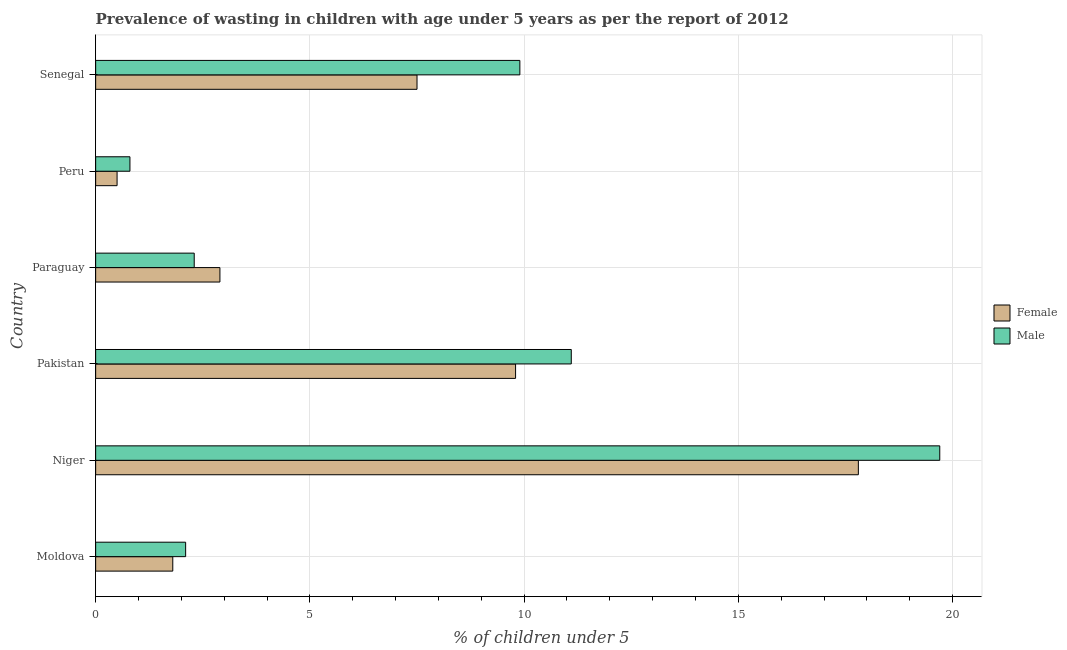How many different coloured bars are there?
Your answer should be compact. 2. Are the number of bars per tick equal to the number of legend labels?
Keep it short and to the point. Yes. Are the number of bars on each tick of the Y-axis equal?
Make the answer very short. Yes. How many bars are there on the 6th tick from the bottom?
Offer a terse response. 2. What is the label of the 6th group of bars from the top?
Provide a short and direct response. Moldova. What is the percentage of undernourished female children in Pakistan?
Your answer should be compact. 9.8. Across all countries, what is the maximum percentage of undernourished male children?
Provide a short and direct response. 19.7. Across all countries, what is the minimum percentage of undernourished male children?
Provide a short and direct response. 0.8. In which country was the percentage of undernourished male children maximum?
Make the answer very short. Niger. In which country was the percentage of undernourished female children minimum?
Your response must be concise. Peru. What is the total percentage of undernourished female children in the graph?
Offer a very short reply. 40.3. What is the difference between the percentage of undernourished male children in Moldova and the percentage of undernourished female children in Paraguay?
Your answer should be very brief. -0.8. What is the average percentage of undernourished male children per country?
Your answer should be compact. 7.65. In how many countries, is the percentage of undernourished male children greater than 9 %?
Offer a terse response. 3. What is the ratio of the percentage of undernourished female children in Niger to that in Senegal?
Offer a terse response. 2.37. What is the difference between the highest and the lowest percentage of undernourished female children?
Offer a terse response. 17.3. In how many countries, is the percentage of undernourished female children greater than the average percentage of undernourished female children taken over all countries?
Provide a succinct answer. 3. Is the sum of the percentage of undernourished male children in Moldova and Paraguay greater than the maximum percentage of undernourished female children across all countries?
Keep it short and to the point. No. What does the 1st bar from the top in Pakistan represents?
Your answer should be very brief. Male. What does the 2nd bar from the bottom in Paraguay represents?
Keep it short and to the point. Male. Are the values on the major ticks of X-axis written in scientific E-notation?
Provide a succinct answer. No. How many legend labels are there?
Provide a succinct answer. 2. How are the legend labels stacked?
Your answer should be compact. Vertical. What is the title of the graph?
Provide a short and direct response. Prevalence of wasting in children with age under 5 years as per the report of 2012. Does "Nitrous oxide emissions" appear as one of the legend labels in the graph?
Give a very brief answer. No. What is the label or title of the X-axis?
Provide a short and direct response.  % of children under 5. What is the  % of children under 5 in Female in Moldova?
Offer a very short reply. 1.8. What is the  % of children under 5 in Male in Moldova?
Offer a terse response. 2.1. What is the  % of children under 5 of Female in Niger?
Keep it short and to the point. 17.8. What is the  % of children under 5 in Male in Niger?
Your answer should be compact. 19.7. What is the  % of children under 5 in Female in Pakistan?
Offer a terse response. 9.8. What is the  % of children under 5 in Male in Pakistan?
Ensure brevity in your answer.  11.1. What is the  % of children under 5 of Female in Paraguay?
Ensure brevity in your answer.  2.9. What is the  % of children under 5 of Male in Paraguay?
Your answer should be compact. 2.3. What is the  % of children under 5 in Female in Peru?
Offer a terse response. 0.5. What is the  % of children under 5 of Male in Peru?
Make the answer very short. 0.8. What is the  % of children under 5 in Male in Senegal?
Offer a terse response. 9.9. Across all countries, what is the maximum  % of children under 5 in Female?
Provide a succinct answer. 17.8. Across all countries, what is the maximum  % of children under 5 of Male?
Offer a very short reply. 19.7. Across all countries, what is the minimum  % of children under 5 in Male?
Your response must be concise. 0.8. What is the total  % of children under 5 of Female in the graph?
Your response must be concise. 40.3. What is the total  % of children under 5 of Male in the graph?
Offer a very short reply. 45.9. What is the difference between the  % of children under 5 in Female in Moldova and that in Niger?
Your answer should be very brief. -16. What is the difference between the  % of children under 5 of Male in Moldova and that in Niger?
Your response must be concise. -17.6. What is the difference between the  % of children under 5 of Male in Moldova and that in Pakistan?
Provide a succinct answer. -9. What is the difference between the  % of children under 5 in Male in Moldova and that in Paraguay?
Provide a short and direct response. -0.2. What is the difference between the  % of children under 5 in Male in Moldova and that in Peru?
Give a very brief answer. 1.3. What is the difference between the  % of children under 5 of Female in Moldova and that in Senegal?
Your answer should be compact. -5.7. What is the difference between the  % of children under 5 in Male in Niger and that in Paraguay?
Offer a very short reply. 17.4. What is the difference between the  % of children under 5 in Female in Niger and that in Peru?
Offer a very short reply. 17.3. What is the difference between the  % of children under 5 of Female in Pakistan and that in Paraguay?
Make the answer very short. 6.9. What is the difference between the  % of children under 5 of Female in Pakistan and that in Peru?
Ensure brevity in your answer.  9.3. What is the difference between the  % of children under 5 in Male in Pakistan and that in Peru?
Offer a terse response. 10.3. What is the difference between the  % of children under 5 of Male in Pakistan and that in Senegal?
Offer a terse response. 1.2. What is the difference between the  % of children under 5 in Male in Paraguay and that in Senegal?
Provide a short and direct response. -7.6. What is the difference between the  % of children under 5 in Female in Peru and that in Senegal?
Provide a short and direct response. -7. What is the difference between the  % of children under 5 of Female in Moldova and the  % of children under 5 of Male in Niger?
Give a very brief answer. -17.9. What is the difference between the  % of children under 5 in Female in Moldova and the  % of children under 5 in Male in Paraguay?
Offer a very short reply. -0.5. What is the difference between the  % of children under 5 in Female in Moldova and the  % of children under 5 in Male in Peru?
Your answer should be very brief. 1. What is the difference between the  % of children under 5 of Female in Niger and the  % of children under 5 of Male in Pakistan?
Provide a short and direct response. 6.7. What is the difference between the  % of children under 5 of Female in Pakistan and the  % of children under 5 of Male in Senegal?
Your answer should be compact. -0.1. What is the average  % of children under 5 of Female per country?
Make the answer very short. 6.72. What is the average  % of children under 5 of Male per country?
Your response must be concise. 7.65. What is the difference between the  % of children under 5 of Female and  % of children under 5 of Male in Niger?
Offer a terse response. -1.9. What is the difference between the  % of children under 5 in Female and  % of children under 5 in Male in Paraguay?
Ensure brevity in your answer.  0.6. What is the difference between the  % of children under 5 of Female and  % of children under 5 of Male in Peru?
Ensure brevity in your answer.  -0.3. What is the ratio of the  % of children under 5 in Female in Moldova to that in Niger?
Your answer should be compact. 0.1. What is the ratio of the  % of children under 5 of Male in Moldova to that in Niger?
Make the answer very short. 0.11. What is the ratio of the  % of children under 5 of Female in Moldova to that in Pakistan?
Give a very brief answer. 0.18. What is the ratio of the  % of children under 5 of Male in Moldova to that in Pakistan?
Your answer should be very brief. 0.19. What is the ratio of the  % of children under 5 in Female in Moldova to that in Paraguay?
Make the answer very short. 0.62. What is the ratio of the  % of children under 5 of Male in Moldova to that in Peru?
Provide a short and direct response. 2.62. What is the ratio of the  % of children under 5 in Female in Moldova to that in Senegal?
Provide a succinct answer. 0.24. What is the ratio of the  % of children under 5 in Male in Moldova to that in Senegal?
Your answer should be very brief. 0.21. What is the ratio of the  % of children under 5 of Female in Niger to that in Pakistan?
Your answer should be very brief. 1.82. What is the ratio of the  % of children under 5 of Male in Niger to that in Pakistan?
Give a very brief answer. 1.77. What is the ratio of the  % of children under 5 of Female in Niger to that in Paraguay?
Provide a succinct answer. 6.14. What is the ratio of the  % of children under 5 in Male in Niger to that in Paraguay?
Your answer should be compact. 8.57. What is the ratio of the  % of children under 5 of Female in Niger to that in Peru?
Provide a succinct answer. 35.6. What is the ratio of the  % of children under 5 of Male in Niger to that in Peru?
Your answer should be very brief. 24.62. What is the ratio of the  % of children under 5 of Female in Niger to that in Senegal?
Provide a succinct answer. 2.37. What is the ratio of the  % of children under 5 in Male in Niger to that in Senegal?
Your answer should be compact. 1.99. What is the ratio of the  % of children under 5 in Female in Pakistan to that in Paraguay?
Give a very brief answer. 3.38. What is the ratio of the  % of children under 5 of Male in Pakistan to that in Paraguay?
Keep it short and to the point. 4.83. What is the ratio of the  % of children under 5 of Female in Pakistan to that in Peru?
Provide a short and direct response. 19.6. What is the ratio of the  % of children under 5 of Male in Pakistan to that in Peru?
Provide a short and direct response. 13.88. What is the ratio of the  % of children under 5 of Female in Pakistan to that in Senegal?
Offer a very short reply. 1.31. What is the ratio of the  % of children under 5 of Male in Pakistan to that in Senegal?
Make the answer very short. 1.12. What is the ratio of the  % of children under 5 in Male in Paraguay to that in Peru?
Your answer should be very brief. 2.88. What is the ratio of the  % of children under 5 in Female in Paraguay to that in Senegal?
Ensure brevity in your answer.  0.39. What is the ratio of the  % of children under 5 in Male in Paraguay to that in Senegal?
Your answer should be compact. 0.23. What is the ratio of the  % of children under 5 of Female in Peru to that in Senegal?
Ensure brevity in your answer.  0.07. What is the ratio of the  % of children under 5 of Male in Peru to that in Senegal?
Give a very brief answer. 0.08. What is the difference between the highest and the second highest  % of children under 5 in Male?
Your answer should be very brief. 8.6. What is the difference between the highest and the lowest  % of children under 5 of Female?
Provide a short and direct response. 17.3. 